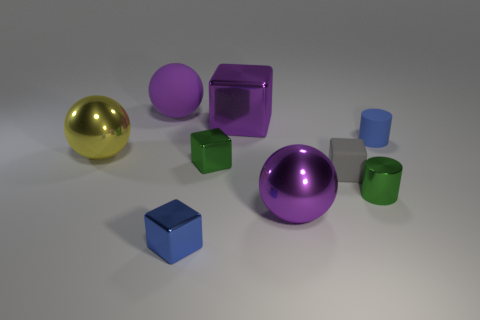Is the green block made of the same material as the large yellow sphere?
Your response must be concise. Yes. How many other things are there of the same material as the green block?
Make the answer very short. 5. Are there more small gray cubes than cubes?
Provide a succinct answer. No. There is a blue thing that is in front of the green block; does it have the same shape as the small gray rubber object?
Provide a succinct answer. Yes. Is the number of tiny blue cylinders less than the number of tiny balls?
Ensure brevity in your answer.  No. There is a blue cylinder that is the same size as the gray matte block; what material is it?
Ensure brevity in your answer.  Rubber. There is a tiny shiny cylinder; is it the same color as the shiny ball behind the small green shiny cube?
Keep it short and to the point. No. Is the number of gray matte things to the right of the green shiny cylinder less than the number of small metallic cylinders?
Offer a terse response. Yes. How many small green metal cylinders are there?
Provide a succinct answer. 1. The blue thing that is to the left of the tiny blue thing that is behind the metallic cylinder is what shape?
Your answer should be very brief. Cube. 